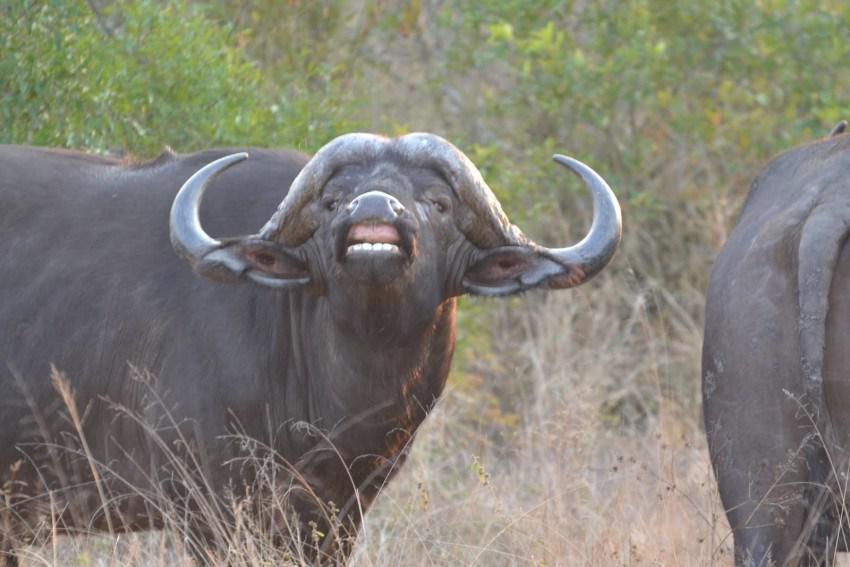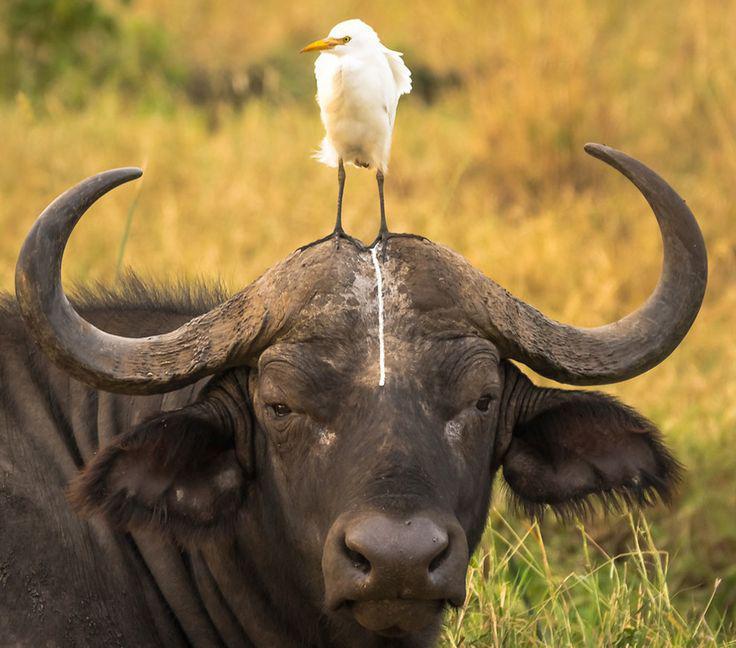The first image is the image on the left, the second image is the image on the right. Analyze the images presented: Is the assertion "There is an animal that is not an ox in at least one image." valid? Answer yes or no. Yes. 